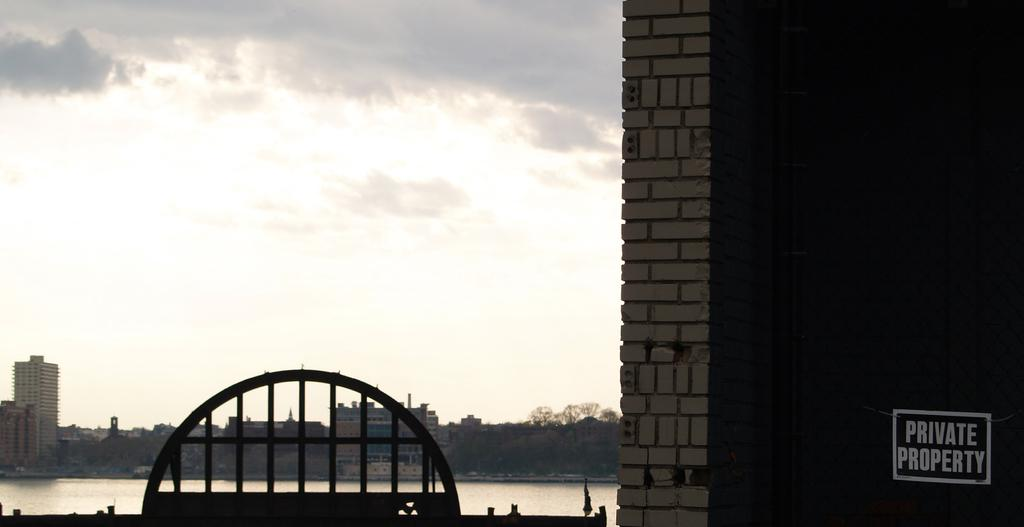<image>
Offer a succinct explanation of the picture presented. a sign on a brick building looking out over a river reads Private Property 